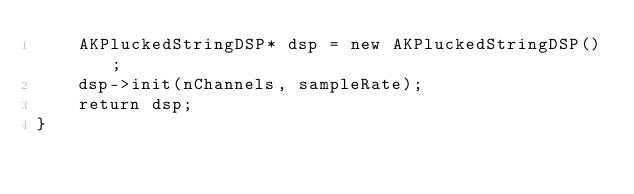<code> <loc_0><loc_0><loc_500><loc_500><_ObjectiveC_>    AKPluckedStringDSP* dsp = new AKPluckedStringDSP();
    dsp->init(nChannels, sampleRate);
    return dsp;
}
</code> 